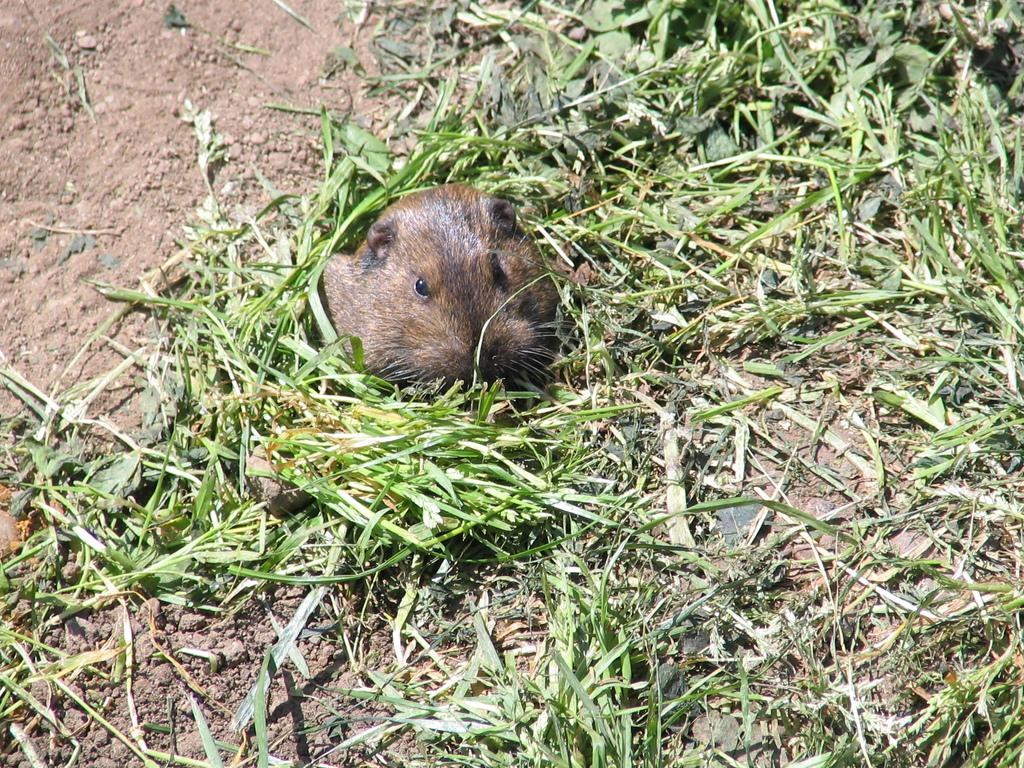What animal is present in the image? There is a rat in the image. What is the rat standing on? The rat is standing on the ground. What is the ground covered with? The ground is covered with grass and mud. What type of bird can be seen flying in the image? There is no bird present in the image; it features a rat standing on the ground. What sense does the rat use to detect the mud on the ground? The provided facts do not mention the rat's senses, so we cannot determine which sense it uses to detect the mud. 